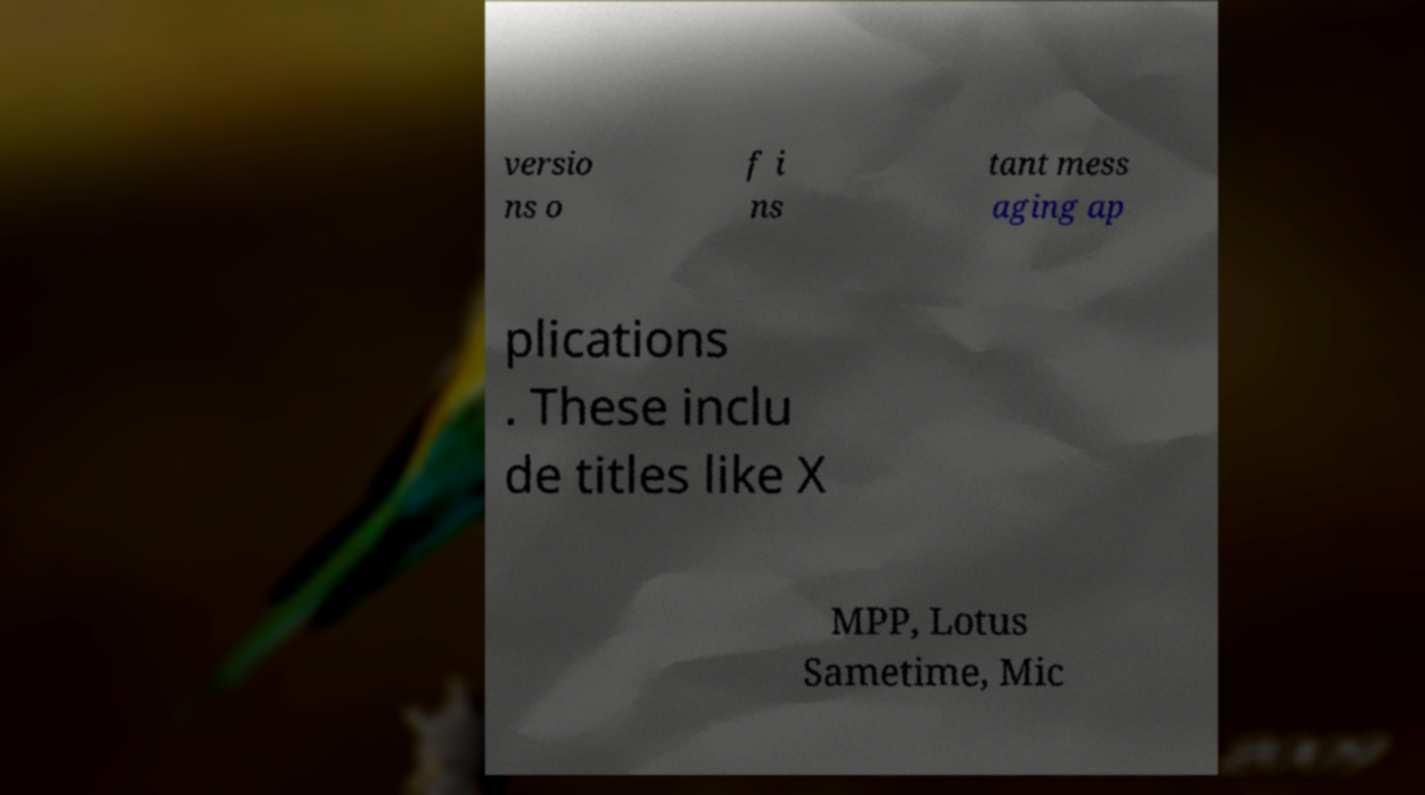Could you extract and type out the text from this image? versio ns o f i ns tant mess aging ap plications . These inclu de titles like X MPP, Lotus Sametime, Mic 